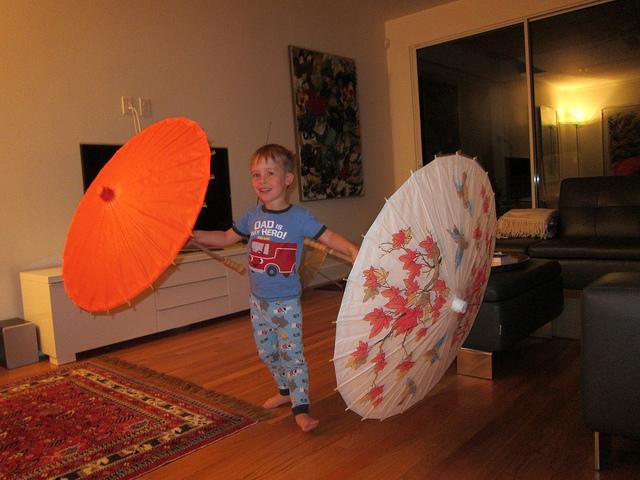How many umbrellas are there?
Concise answer only. 2. What type of floor is in the picture?
Short answer required. Wood. What kind of truck is on the boy's shirt?
Short answer required. Fire truck. 